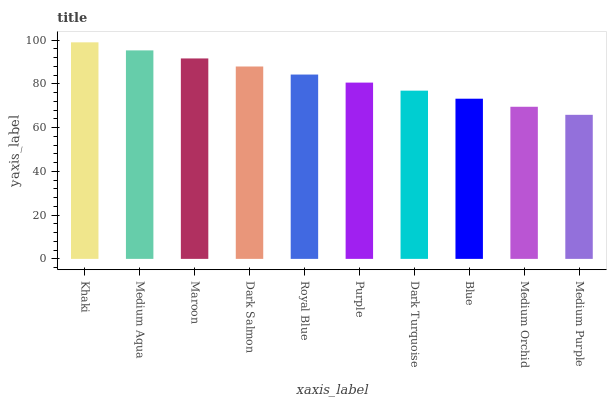Is Medium Purple the minimum?
Answer yes or no. Yes. Is Khaki the maximum?
Answer yes or no. Yes. Is Medium Aqua the minimum?
Answer yes or no. No. Is Medium Aqua the maximum?
Answer yes or no. No. Is Khaki greater than Medium Aqua?
Answer yes or no. Yes. Is Medium Aqua less than Khaki?
Answer yes or no. Yes. Is Medium Aqua greater than Khaki?
Answer yes or no. No. Is Khaki less than Medium Aqua?
Answer yes or no. No. Is Royal Blue the high median?
Answer yes or no. Yes. Is Purple the low median?
Answer yes or no. Yes. Is Khaki the high median?
Answer yes or no. No. Is Dark Salmon the low median?
Answer yes or no. No. 